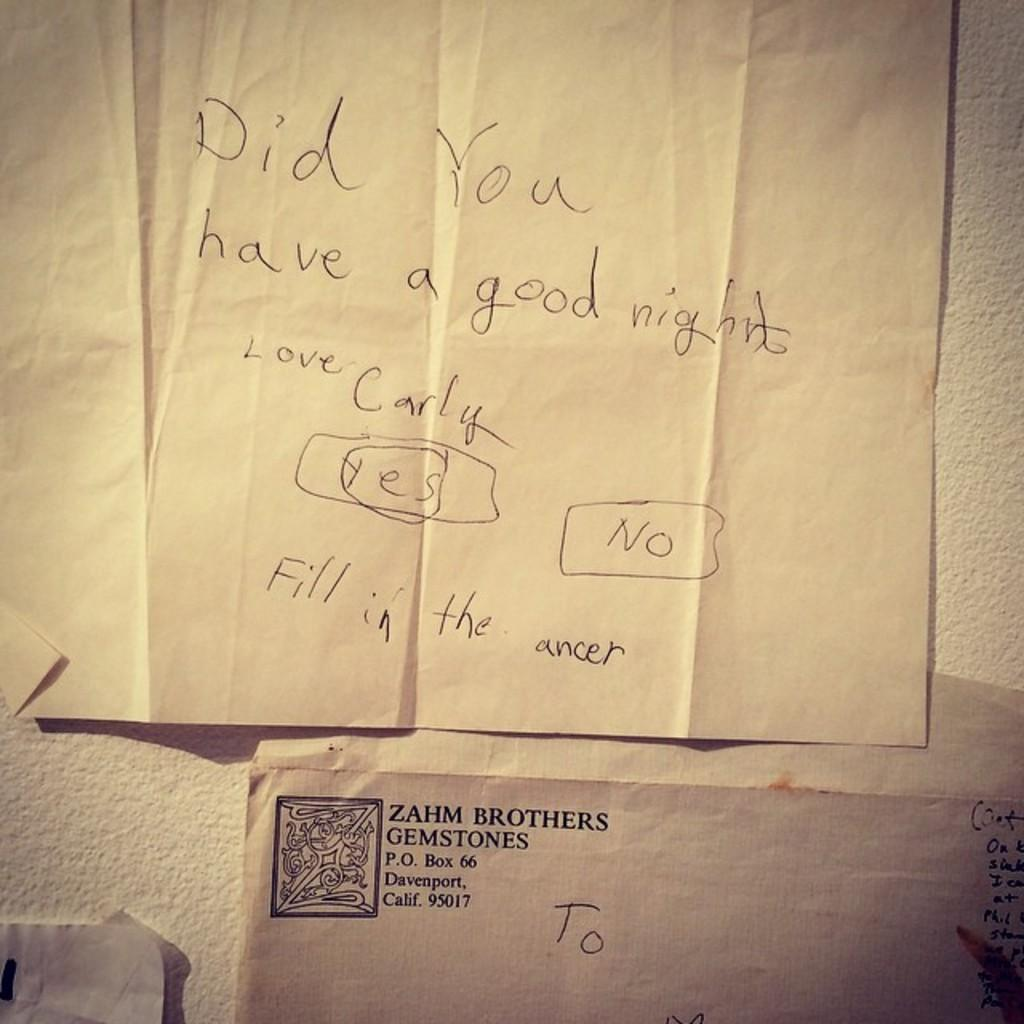<image>
Offer a succinct explanation of the picture presented. A note appears to have come from an envelope from Zahm Brothers Gemstones. 